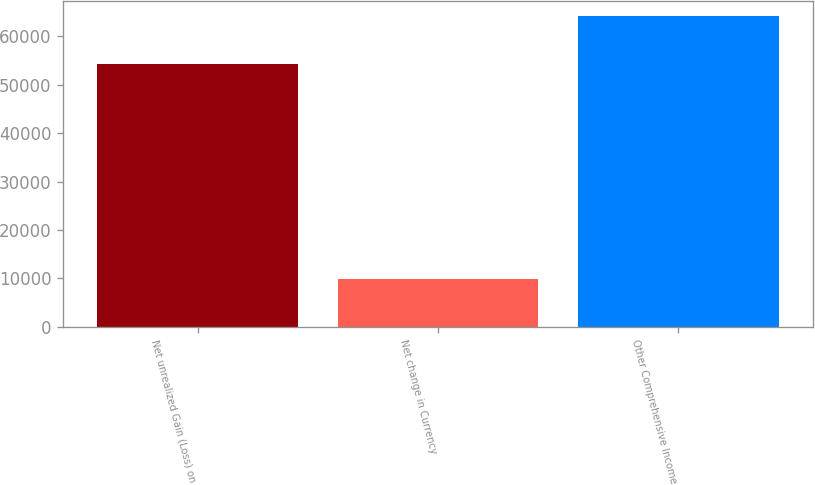<chart> <loc_0><loc_0><loc_500><loc_500><bar_chart><fcel>Net unrealized Gain (Loss) on<fcel>Net change in Currency<fcel>Other Comprehensive Income<nl><fcel>54377<fcel>9790<fcel>64167<nl></chart> 